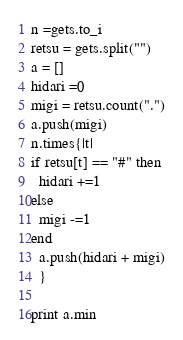Convert code to text. <code><loc_0><loc_0><loc_500><loc_500><_Ruby_>n =gets.to_i
retsu = gets.split("")
a = []
hidari =0
migi = retsu.count(".")
a.push(migi)
n.times{|t|
if retsu[t] == "#" then
  hidari +=1
else
  migi -=1
end
  a.push(hidari + migi)
  }

print a.min</code> 